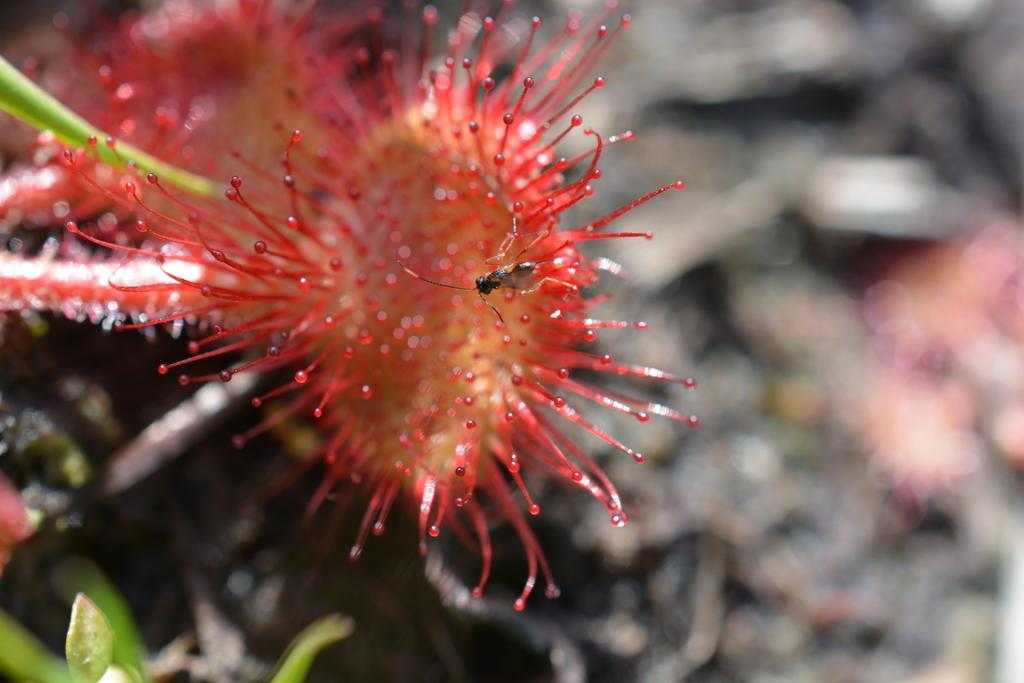What type of flower is present in the image? There is a red color flower in the image. Is there anything else on the flower besides the petals? Yes, there is an insect on the flower. How would you describe the background of the image? The background of the image is blurred. How many cats can be seen walking on the steps in the image? There are no cats or steps present in the image. 